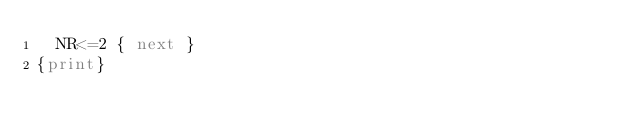<code> <loc_0><loc_0><loc_500><loc_500><_Awk_>  NR<=2 { next }
{print}
</code> 